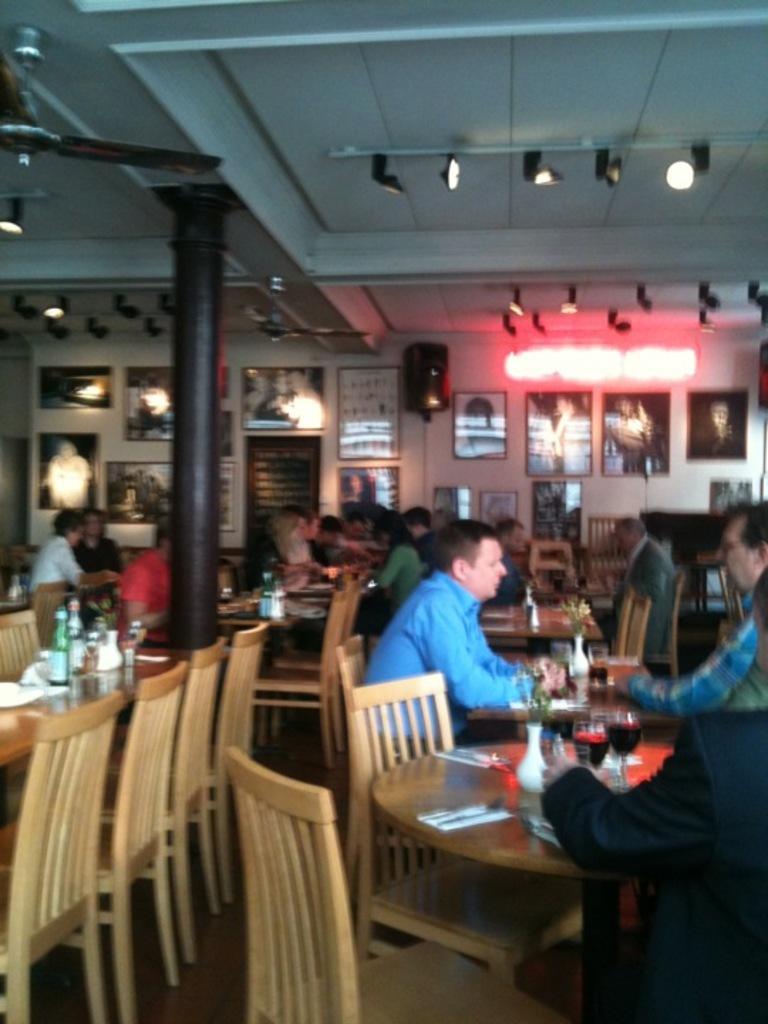Could you give a brief overview of what you see in this image? This image is clicked in a restaurant. There are many chairs and tables in this image. In the front there are two persons sitting and talking. both are wearing blue shirts. To the right, the person sitting and wearing a suit. In the background, there is wall on which frames are fixed. 